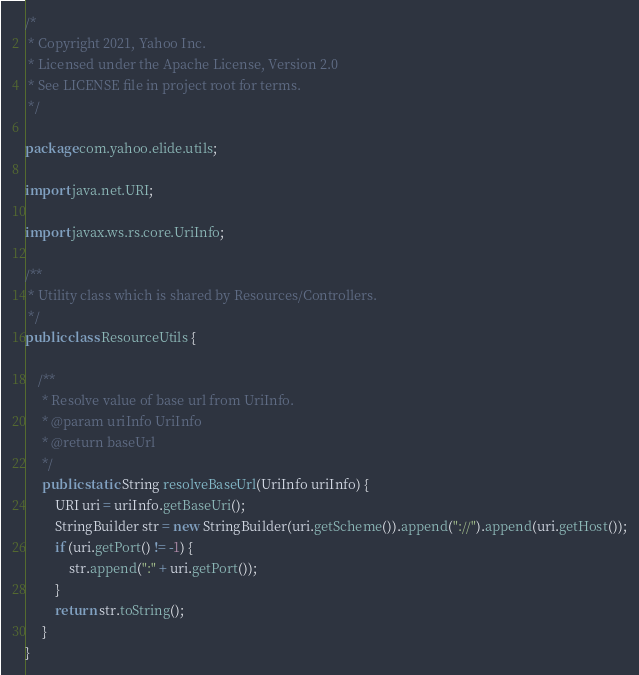Convert code to text. <code><loc_0><loc_0><loc_500><loc_500><_Java_>/*
 * Copyright 2021, Yahoo Inc.
 * Licensed under the Apache License, Version 2.0
 * See LICENSE file in project root for terms.
 */

package com.yahoo.elide.utils;

import java.net.URI;

import javax.ws.rs.core.UriInfo;

/**
 * Utility class which is shared by Resources/Controllers.
 */
public class ResourceUtils {

    /**
     * Resolve value of base url from UriInfo.
     * @param uriInfo UriInfo
     * @return baseUrl
     */
     public static String resolveBaseUrl(UriInfo uriInfo) {
         URI uri = uriInfo.getBaseUri();
         StringBuilder str = new StringBuilder(uri.getScheme()).append("://").append(uri.getHost());
         if (uri.getPort() != -1) {
             str.append(":" + uri.getPort());
         }
         return str.toString();
     }
}
</code> 